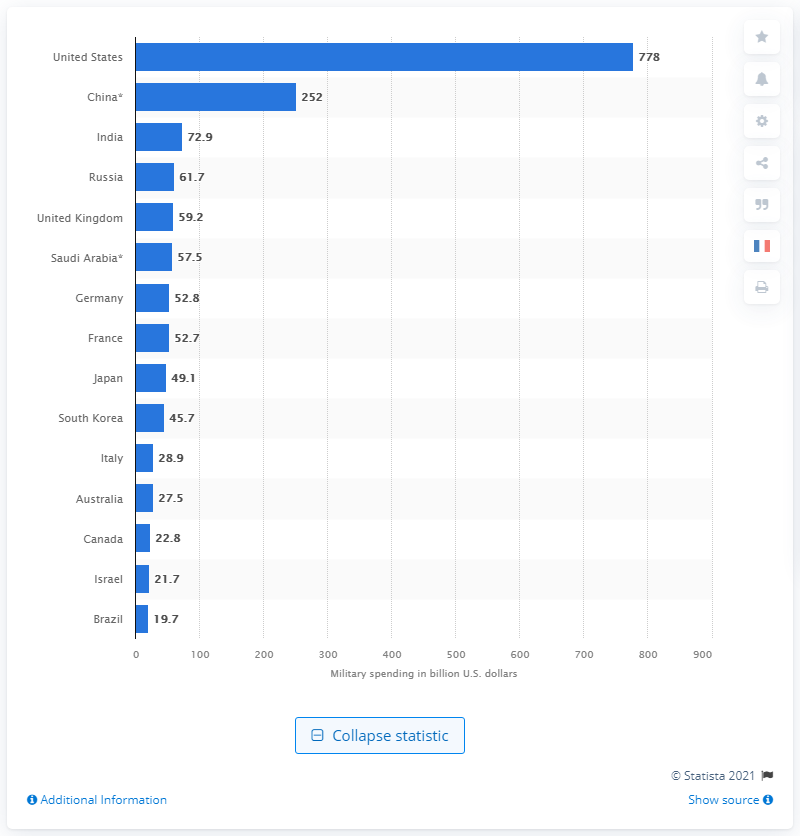Identify some key points in this picture. The German government spent 52.8 billion dollars on the military in 2020. 